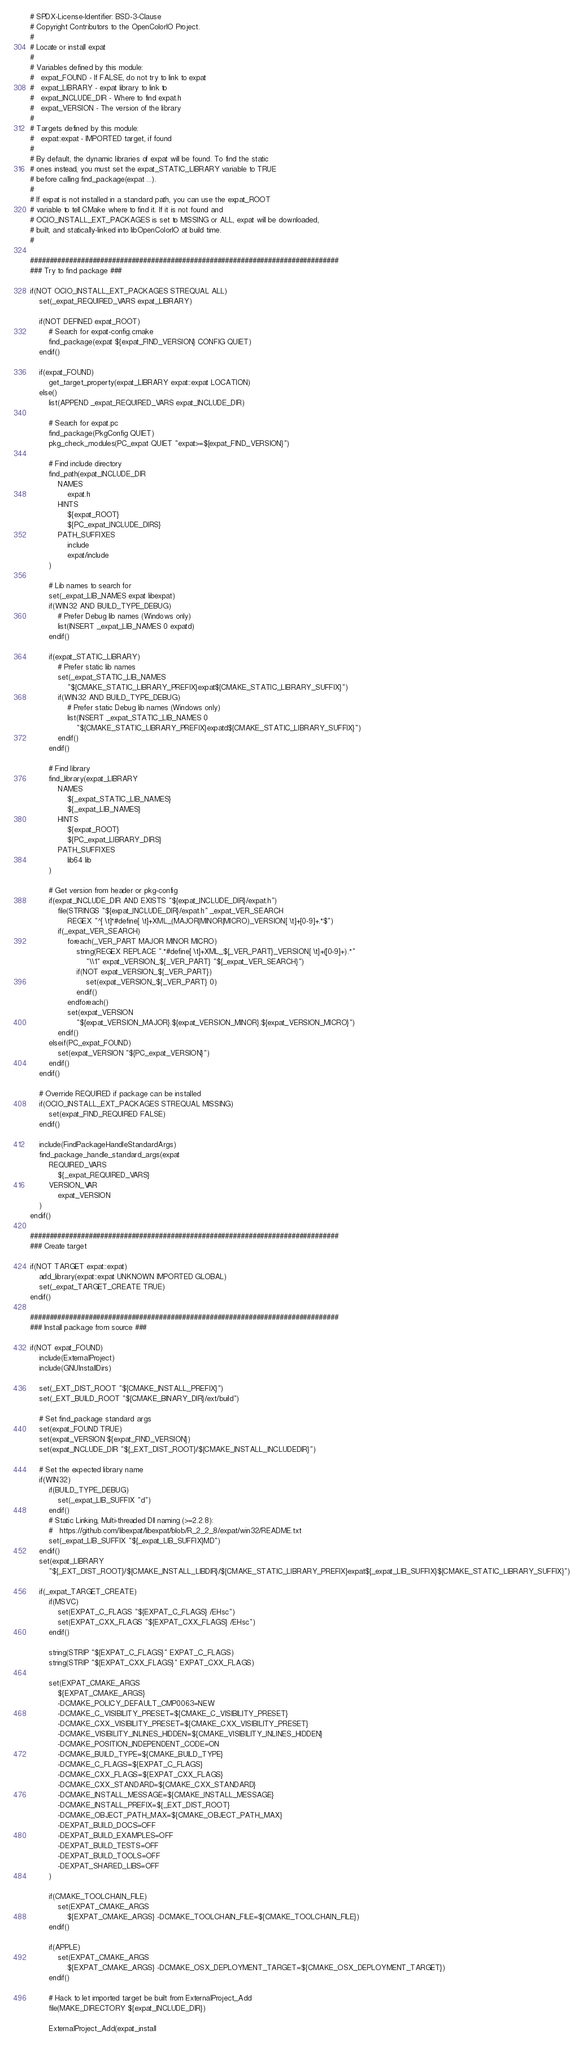Convert code to text. <code><loc_0><loc_0><loc_500><loc_500><_CMake_># SPDX-License-Identifier: BSD-3-Clause
# Copyright Contributors to the OpenColorIO Project.
#
# Locate or install expat
#
# Variables defined by this module:
#   expat_FOUND - If FALSE, do not try to link to expat
#   expat_LIBRARY - expat library to link to
#   expat_INCLUDE_DIR - Where to find expat.h
#   expat_VERSION - The version of the library
#
# Targets defined by this module:
#   expat::expat - IMPORTED target, if found
#
# By default, the dynamic libraries of expat will be found. To find the static 
# ones instead, you must set the expat_STATIC_LIBRARY variable to TRUE 
# before calling find_package(expat ...).
#
# If expat is not installed in a standard path, you can use the expat_ROOT 
# variable to tell CMake where to find it. If it is not found and 
# OCIO_INSTALL_EXT_PACKAGES is set to MISSING or ALL, expat will be downloaded, 
# built, and statically-linked into libOpenColorIO at build time.
#

###############################################################################
### Try to find package ###

if(NOT OCIO_INSTALL_EXT_PACKAGES STREQUAL ALL)
    set(_expat_REQUIRED_VARS expat_LIBRARY)

    if(NOT DEFINED expat_ROOT)
        # Search for expat-config.cmake
        find_package(expat ${expat_FIND_VERSION} CONFIG QUIET)
    endif()

    if(expat_FOUND)
        get_target_property(expat_LIBRARY expat::expat LOCATION)
    else()
        list(APPEND _expat_REQUIRED_VARS expat_INCLUDE_DIR)

        # Search for expat.pc
        find_package(PkgConfig QUIET)
        pkg_check_modules(PC_expat QUIET "expat>=${expat_FIND_VERSION}")

        # Find include directory
        find_path(expat_INCLUDE_DIR
            NAMES
                expat.h
            HINTS
                ${expat_ROOT}
                ${PC_expat_INCLUDE_DIRS}
            PATH_SUFFIXES
                include
                expat/include
        )

        # Lib names to search for
        set(_expat_LIB_NAMES expat libexpat)
        if(WIN32 AND BUILD_TYPE_DEBUG)
            # Prefer Debug lib names (Windows only)
            list(INSERT _expat_LIB_NAMES 0 expatd)
        endif()

        if(expat_STATIC_LIBRARY)
            # Prefer static lib names
            set(_expat_STATIC_LIB_NAMES 
                "${CMAKE_STATIC_LIBRARY_PREFIX}expat${CMAKE_STATIC_LIBRARY_SUFFIX}")
            if(WIN32 AND BUILD_TYPE_DEBUG)
                # Prefer static Debug lib names (Windows only)
                list(INSERT _expat_STATIC_LIB_NAMES 0
                    "${CMAKE_STATIC_LIBRARY_PREFIX}expatd${CMAKE_STATIC_LIBRARY_SUFFIX}")
            endif()
        endif()

        # Find library
        find_library(expat_LIBRARY
            NAMES
                ${_expat_STATIC_LIB_NAMES}
                ${_expat_LIB_NAMES}
            HINTS
                ${expat_ROOT}
                ${PC_expat_LIBRARY_DIRS}
            PATH_SUFFIXES
                lib64 lib 
        )

        # Get version from header or pkg-config
        if(expat_INCLUDE_DIR AND EXISTS "${expat_INCLUDE_DIR}/expat.h")
            file(STRINGS "${expat_INCLUDE_DIR}/expat.h" _expat_VER_SEARCH 
                REGEX "^[ \t]*#define[ \t]+XML_(MAJOR|MINOR|MICRO)_VERSION[ \t]+[0-9]+.*$")
            if(_expat_VER_SEARCH)
                foreach(_VER_PART MAJOR MINOR MICRO)
                    string(REGEX REPLACE ".*#define[ \t]+XML_${_VER_PART}_VERSION[ \t]+([0-9]+).*" 
                        "\\1" expat_VERSION_${_VER_PART} "${_expat_VER_SEARCH}")
                    if(NOT expat_VERSION_${_VER_PART})
                        set(expat_VERSION_${_VER_PART} 0)
                    endif()
                endforeach()
                set(expat_VERSION 
                    "${expat_VERSION_MAJOR}.${expat_VERSION_MINOR}.${expat_VERSION_MICRO}")
            endif()
        elseif(PC_expat_FOUND)
            set(expat_VERSION "${PC_expat_VERSION}")
        endif()
    endif()

    # Override REQUIRED if package can be installed
    if(OCIO_INSTALL_EXT_PACKAGES STREQUAL MISSING)
        set(expat_FIND_REQUIRED FALSE)
    endif()

    include(FindPackageHandleStandardArgs)
    find_package_handle_standard_args(expat
        REQUIRED_VARS 
            ${_expat_REQUIRED_VARS}
        VERSION_VAR
            expat_VERSION
    )
endif()

###############################################################################
### Create target

if(NOT TARGET expat::expat)
    add_library(expat::expat UNKNOWN IMPORTED GLOBAL)
    set(_expat_TARGET_CREATE TRUE)
endif()

###############################################################################
### Install package from source ###

if(NOT expat_FOUND)
    include(ExternalProject)
    include(GNUInstallDirs)

    set(_EXT_DIST_ROOT "${CMAKE_INSTALL_PREFIX}")
    set(_EXT_BUILD_ROOT "${CMAKE_BINARY_DIR}/ext/build")

    # Set find_package standard args
    set(expat_FOUND TRUE)
    set(expat_VERSION ${expat_FIND_VERSION})
    set(expat_INCLUDE_DIR "${_EXT_DIST_ROOT}/${CMAKE_INSTALL_INCLUDEDIR}")

    # Set the expected library name
    if(WIN32)
        if(BUILD_TYPE_DEBUG)
            set(_expat_LIB_SUFFIX "d")
        endif()
        # Static Linking, Multi-threaded Dll naming (>=2.2.8):
        #   https://github.com/libexpat/libexpat/blob/R_2_2_8/expat/win32/README.txt
        set(_expat_LIB_SUFFIX "${_expat_LIB_SUFFIX}MD")
    endif()
    set(expat_LIBRARY
        "${_EXT_DIST_ROOT}/${CMAKE_INSTALL_LIBDIR}/${CMAKE_STATIC_LIBRARY_PREFIX}expat${_expat_LIB_SUFFIX}${CMAKE_STATIC_LIBRARY_SUFFIX}")

    if(_expat_TARGET_CREATE)
        if(MSVC)
            set(EXPAT_C_FLAGS "${EXPAT_C_FLAGS} /EHsc")
            set(EXPAT_CXX_FLAGS "${EXPAT_CXX_FLAGS} /EHsc")
        endif()

        string(STRIP "${EXPAT_C_FLAGS}" EXPAT_C_FLAGS)
        string(STRIP "${EXPAT_CXX_FLAGS}" EXPAT_CXX_FLAGS)

        set(EXPAT_CMAKE_ARGS
            ${EXPAT_CMAKE_ARGS}
            -DCMAKE_POLICY_DEFAULT_CMP0063=NEW
            -DCMAKE_C_VISIBILITY_PRESET=${CMAKE_C_VISIBILITY_PRESET}
            -DCMAKE_CXX_VISIBILITY_PRESET=${CMAKE_CXX_VISIBILITY_PRESET}
            -DCMAKE_VISIBILITY_INLINES_HIDDEN=${CMAKE_VISIBILITY_INLINES_HIDDEN}
            -DCMAKE_POSITION_INDEPENDENT_CODE=ON
            -DCMAKE_BUILD_TYPE=${CMAKE_BUILD_TYPE}
            -DCMAKE_C_FLAGS=${EXPAT_C_FLAGS}
            -DCMAKE_CXX_FLAGS=${EXPAT_CXX_FLAGS}
            -DCMAKE_CXX_STANDARD=${CMAKE_CXX_STANDARD}
            -DCMAKE_INSTALL_MESSAGE=${CMAKE_INSTALL_MESSAGE}
            -DCMAKE_INSTALL_PREFIX=${_EXT_DIST_ROOT}
            -DCMAKE_OBJECT_PATH_MAX=${CMAKE_OBJECT_PATH_MAX}
            -DEXPAT_BUILD_DOCS=OFF
            -DEXPAT_BUILD_EXAMPLES=OFF
            -DEXPAT_BUILD_TESTS=OFF
            -DEXPAT_BUILD_TOOLS=OFF
            -DEXPAT_SHARED_LIBS=OFF
        )

        if(CMAKE_TOOLCHAIN_FILE)
            set(EXPAT_CMAKE_ARGS
                ${EXPAT_CMAKE_ARGS} -DCMAKE_TOOLCHAIN_FILE=${CMAKE_TOOLCHAIN_FILE})
        endif()

        if(APPLE)
            set(EXPAT_CMAKE_ARGS
                ${EXPAT_CMAKE_ARGS} -DCMAKE_OSX_DEPLOYMENT_TARGET=${CMAKE_OSX_DEPLOYMENT_TARGET})
        endif()

        # Hack to let imported target be built from ExternalProject_Add
        file(MAKE_DIRECTORY ${expat_INCLUDE_DIR})

        ExternalProject_Add(expat_install</code> 